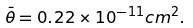<formula> <loc_0><loc_0><loc_500><loc_500>\bar { \theta } = 0 . 2 2 \times 1 0 ^ { - 1 1 } c m ^ { 2 } .</formula> 